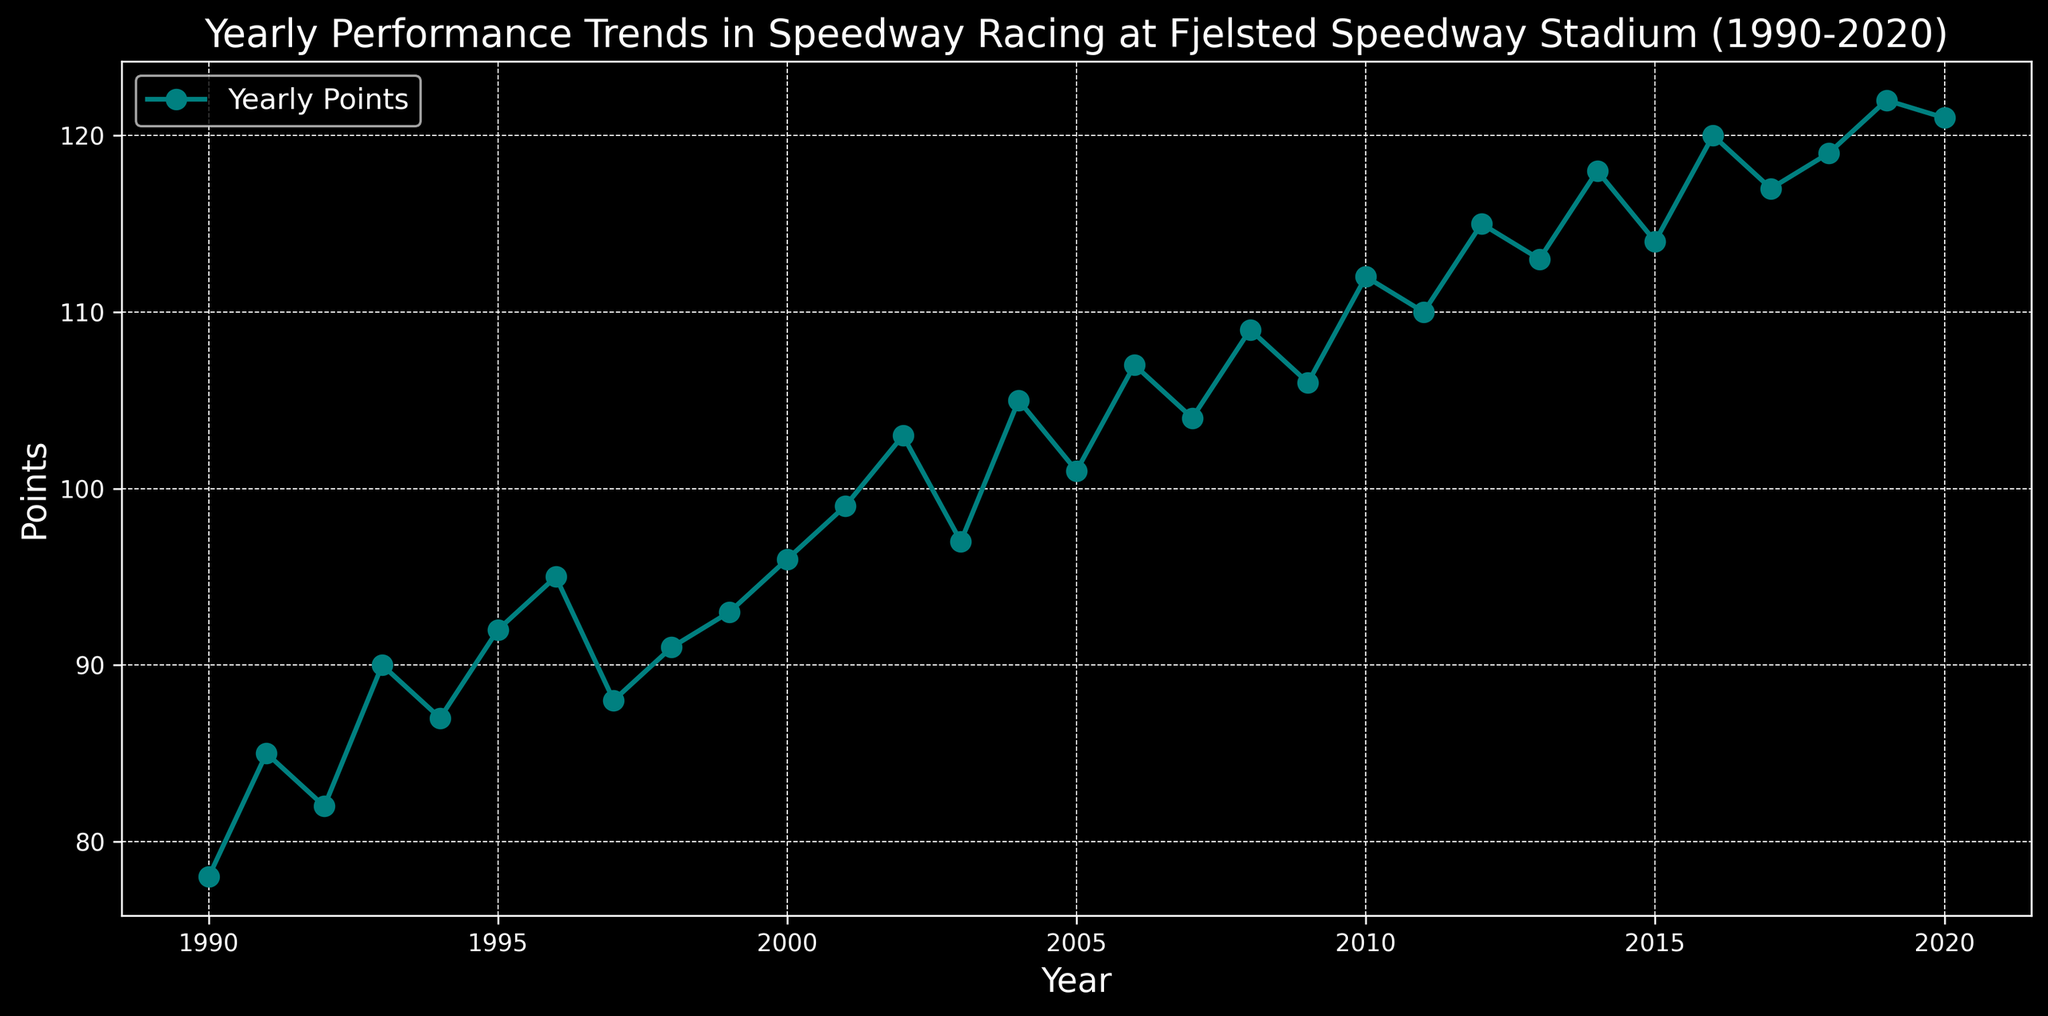Which year had the highest points? By observing the highest point on the y-axis of the plot, we can see that the peak point, indicating the highest score, occurs in the year 2019.
Answer: 2019 What is the difference in points between the years 2000 and 2001? From the chart, identify the values for the years 2000 and 2001, which are 96 and 99 points respectively. The difference between these values is 99 - 96 = 3 points.
Answer: 3 In which year did the points surpass 100 for the first time? On the chart, find the point where the yearly points first exceed 100. This occurs in the year 2002, the first year a point value of 103 is recorded.
Answer: 2002 Which year experienced a drop in points from the previous year after a consistent increase? By following the plotted line, we see a consistent increase and then a visible drop in points from 2002 to 2003, where it falls from 103 to 97 points.
Answer: 2003 What is the average points scored from 2010 to 2020? List the points from 2010 to 2020 (112, 110, 115, 113, 118, 114, 120, 117, 119, 122, 121). The sum is 1291. There are 11 years in total, so the average is 1291/11 ≈ 117.36.
Answer: 117.36 How many years had points equal to or greater than 110? Look at the plot and count all the years that had a points value of 110 or higher. These years are: 2010, 2011, 2012, 2013, 2014, 2015, 2016, 2017, 2018, 2019, 2020. That totals to 11 years.
Answer: 11 What is the trend of the points between 1997 and 2000? From 1997, the points first decrease to 88 in 1997, then increase in subsequent years (91 in 1998, 93 in 1999, 96 in 2000). Overall, there is an increasing trend.
Answer: Increasing What is the median value of the points scored in the 1990s? List the points for the years 1990-1999 (78, 85, 82, 90, 87, 92, 95, 88, 91, 93). Order them (78, 82, 85, 87, 88, 90, 91, 92, 93, 95) and identify the median, which is the average of the 5th and 6th values (88 and 90). Thus, (88 + 90) / 2 = 89.
Answer: 89 Looking at the visual trend from 2001 to 2010, which year saw the highest single-year increase in points? Check the differences between subsequent years' points in this range. The largest increase appears between 2005 (101 points) and 2006 (107 points), a rise of 6 points.
Answer: 2006 Are there any years where the points remained the same as the previous year? By visually scanning the plot, we notice that no consecutive years share the same points value, indicating no years with identical points as the previous year.
Answer: No 